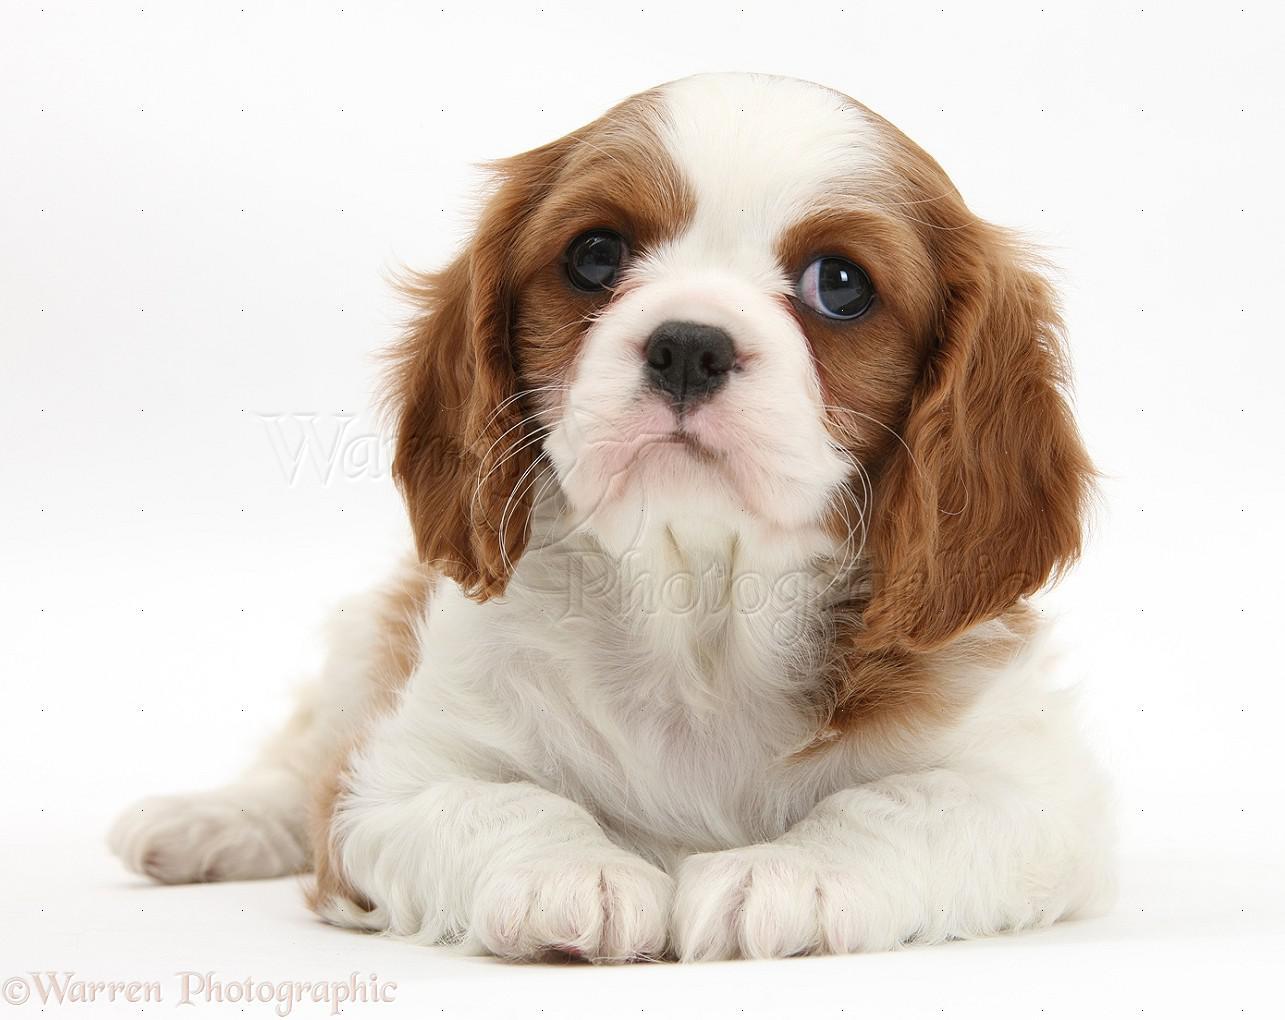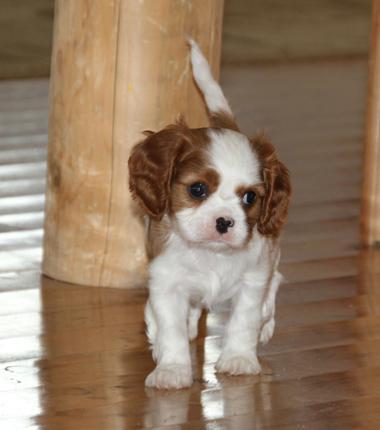The first image is the image on the left, the second image is the image on the right. Examine the images to the left and right. Is the description "there are three animals." accurate? Answer yes or no. No. The first image is the image on the left, the second image is the image on the right. For the images displayed, is the sentence "There are no more than two animals" factually correct? Answer yes or no. Yes. 